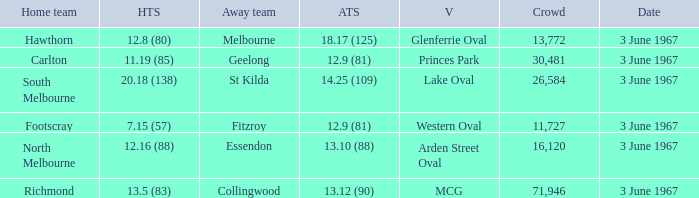What was Hawthorn's score as the home team? 12.8 (80). 